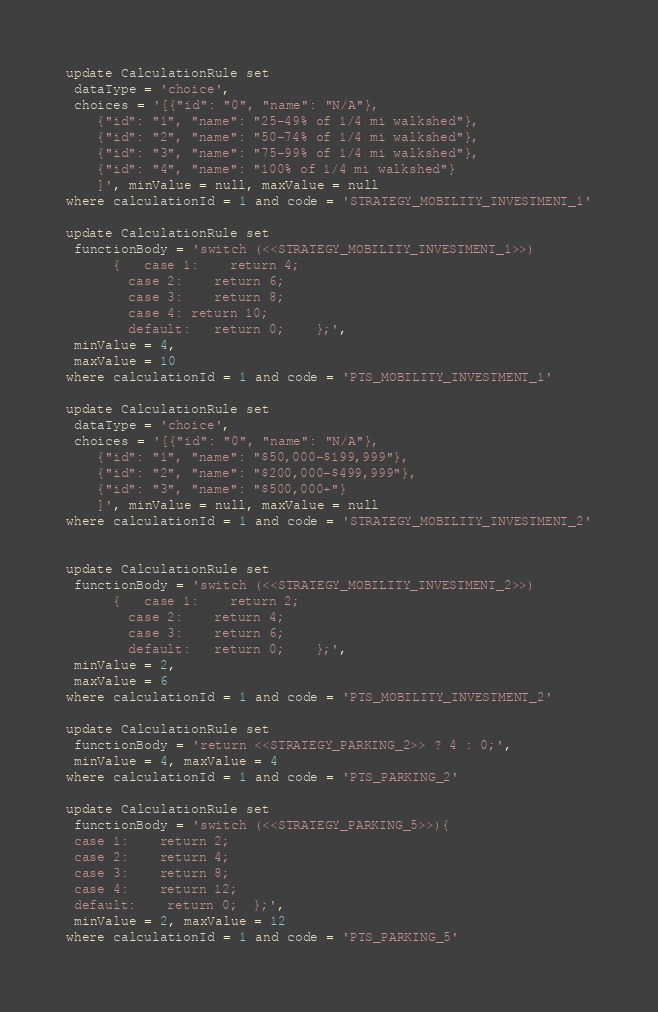Convert code to text. <code><loc_0><loc_0><loc_500><loc_500><_SQL_>update CalculationRule set
 dataType = 'choice',
 choices = '[{"id": "0", "name": "N/A"},
    {"id": "1", "name": "25-49% of 1/4 mi walkshed"},
    {"id": "2", "name": "50-74% of 1/4 mi walkshed"},
    {"id": "3", "name": "75-99% of 1/4 mi walkshed"},
	{"id": "4", "name": "100% of 1/4 mi walkshed"}
	]', minValue = null, maxValue = null
where calculationId = 1 and code = 'STRATEGY_MOBILITY_INVESTMENT_1'

update CalculationRule set
 functionBody = 'switch (<<STRATEGY_MOBILITY_INVESTMENT_1>>)
      {   case 1:    return 4;   
        case 2:    return 6;   
        case 3:    return 8;   
		case 4:	return 10;
        default:   return 0;  	};',
 minValue = 4,
 maxValue = 10
where calculationId = 1 and code = 'PTS_MOBILITY_INVESTMENT_1'

update CalculationRule set
 dataType = 'choice',
 choices = '[{"id": "0", "name": "N/A"},
    {"id": "1", "name": "$50,000-$199,999"},
    {"id": "2", "name": "$200,000-$499,999"},
    {"id": "3", "name": "$500,000+"}
	]', minValue = null, maxValue = null
where calculationId = 1 and code = 'STRATEGY_MOBILITY_INVESTMENT_2'


update CalculationRule set
 functionBody = 'switch (<<STRATEGY_MOBILITY_INVESTMENT_2>>)
      {   case 1:    return 2;   
        case 2:    return 4;   
        case 3:    return 6;   
        default:   return 0;  	};',
 minValue = 2,
 maxValue = 6
where calculationId = 1 and code = 'PTS_MOBILITY_INVESTMENT_2'

update CalculationRule set
 functionBody = 'return <<STRATEGY_PARKING_2>> ? 4 : 0;',
 minValue = 4, maxValue = 4
where calculationId = 1 and code = 'PTS_PARKING_2'

update CalculationRule set
 functionBody = 'switch (<<STRATEGY_PARKING_5>>){   
 case 1:    return 2;   
 case 2:    return 4;   
 case 3:    return 8;   
 case 4:    return 12;  
 default:    return 0;  };',
 minValue = 2, maxValue = 12
where calculationId = 1 and code = 'PTS_PARKING_5'</code> 